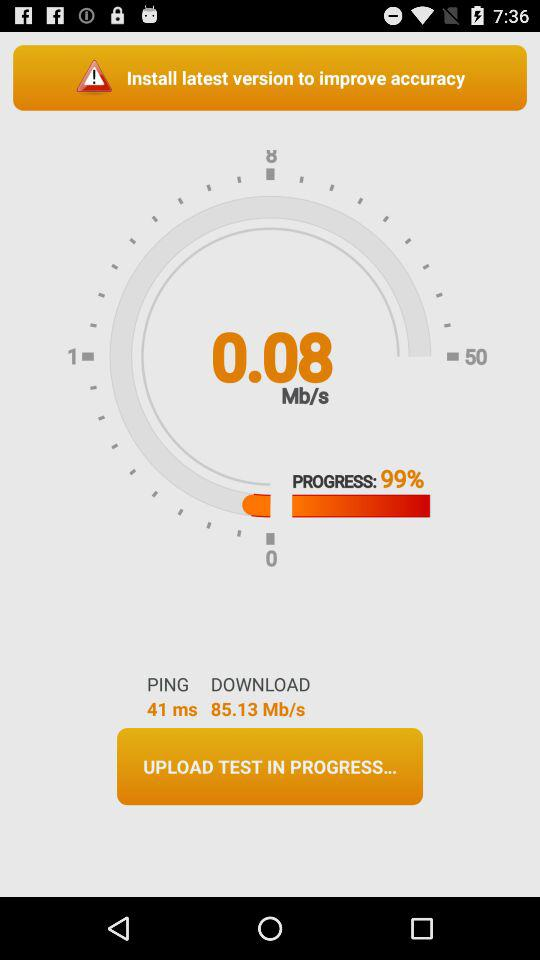What is the time of the last ping? The time is 41 ms. 